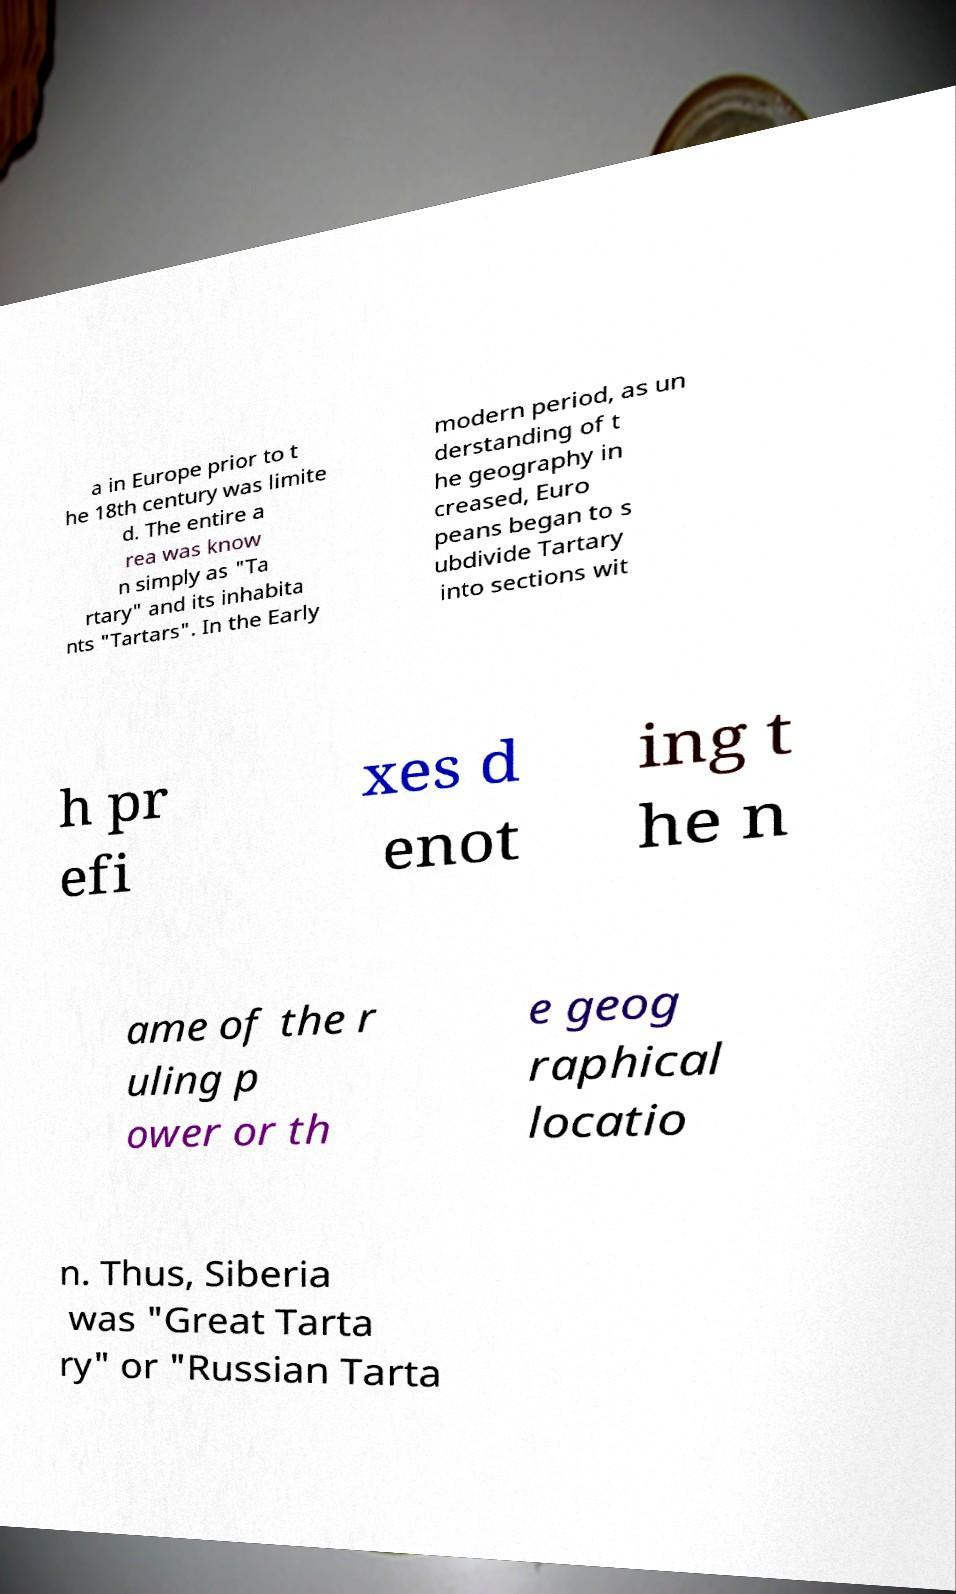I need the written content from this picture converted into text. Can you do that? a in Europe prior to t he 18th century was limite d. The entire a rea was know n simply as "Ta rtary" and its inhabita nts "Tartars". In the Early modern period, as un derstanding of t he geography in creased, Euro peans began to s ubdivide Tartary into sections wit h pr efi xes d enot ing t he n ame of the r uling p ower or th e geog raphical locatio n. Thus, Siberia was "Great Tarta ry" or "Russian Tarta 